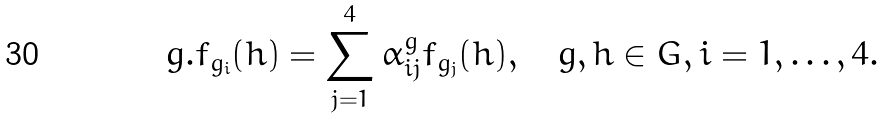<formula> <loc_0><loc_0><loc_500><loc_500>g . f _ { g _ { i } } ( h ) = \sum _ { j = 1 } ^ { 4 } \alpha _ { i j } ^ { g } f _ { g _ { j } } ( h ) , \quad g , h \in G , i = 1 , \dots , 4 .</formula> 